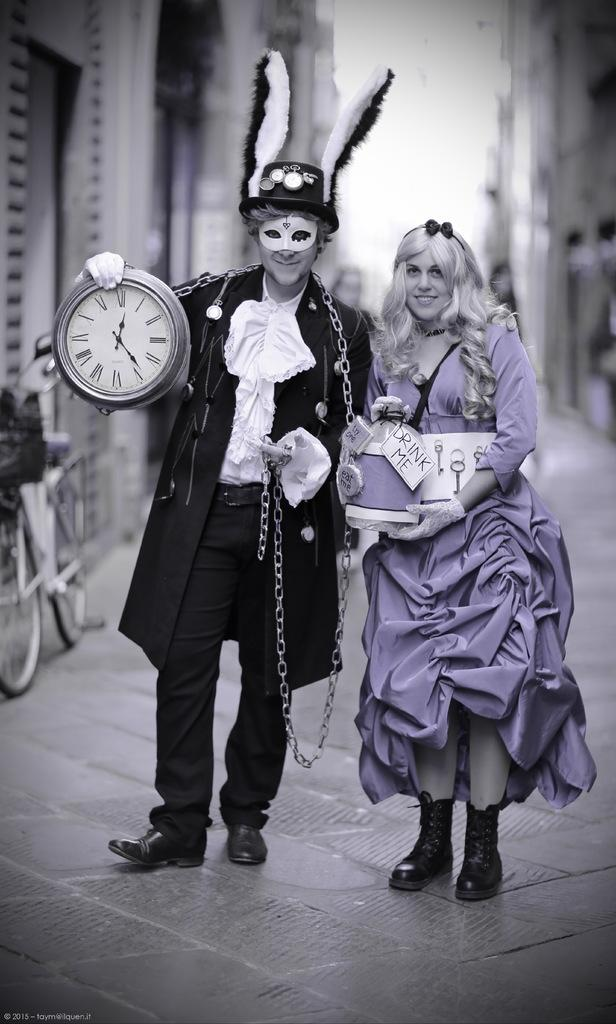<image>
Describe the image concisely. An alice and rabbit cosplay with a sign saying Drink Me 